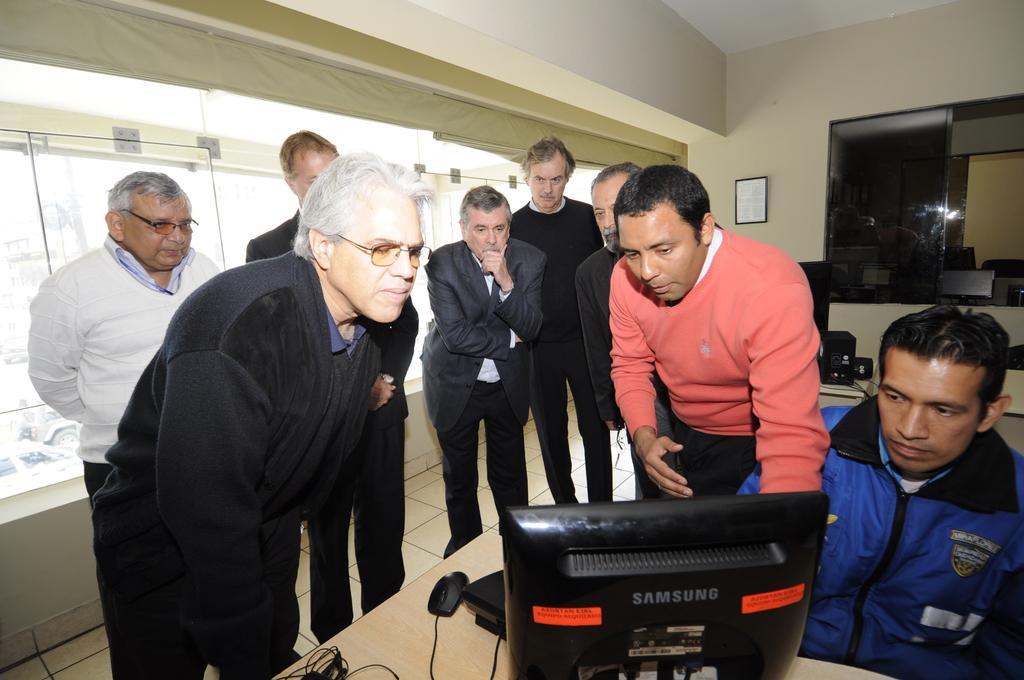In one or two sentences, can you explain what this image depicts? This picture is clicked inside the room. In the foreground we can see a monitor, mouse and some other objects are placed on the top of the table and we can see a person sitting and we can see the group of persons standing on the floor. In the background we can see an object hanging on the wall and we can see the windows, window blinds, roof and many other objects. 